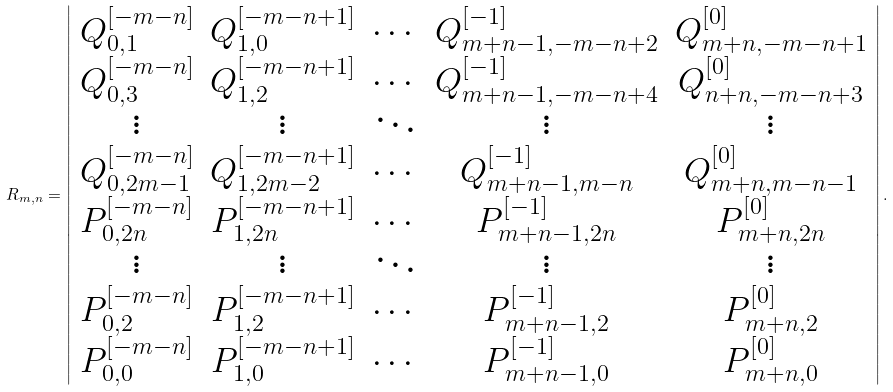Convert formula to latex. <formula><loc_0><loc_0><loc_500><loc_500>R _ { m , n } = \left | \begin{array} { c c c c c } Q _ { 0 , 1 } ^ { [ - m - n ] } & Q _ { 1 , 0 } ^ { [ - m - n + 1 ] } & \cdots & Q _ { m + n - 1 , - m - n + 2 } ^ { [ - 1 ] } & Q _ { m + n , - m - n + 1 } ^ { [ 0 ] } \\ Q _ { 0 , 3 } ^ { [ - m - n ] } & Q _ { 1 , 2 } ^ { [ - m - n + 1 ] } & \cdots & Q _ { m + n - 1 , - m - n + 4 } ^ { [ - 1 ] } & Q _ { n + n , - m - n + 3 } ^ { [ 0 ] } \\ \vdots & \vdots & \ddots & \vdots & \vdots \\ Q _ { 0 , 2 m - 1 } ^ { [ - m - n ] } & Q _ { 1 , 2 m - 2 } ^ { [ - m - n + 1 ] } & \cdots & Q _ { m + n - 1 , m - n } ^ { [ - 1 ] } & Q _ { m + n , m - n - 1 } ^ { [ 0 ] } \\ P _ { 0 , 2 n } ^ { [ - m - n ] } & P _ { 1 , 2 n } ^ { [ - m - n + 1 ] } & \cdots & P _ { m + n - 1 , 2 n } ^ { [ - 1 ] } & P _ { m + n , 2 n } ^ { [ 0 ] } \\ \vdots & \vdots & \ddots & \vdots & \vdots \\ P _ { 0 , 2 } ^ { [ - m - n ] } & P _ { 1 , 2 } ^ { [ - m - n + 1 ] } & \cdots & P _ { m + n - 1 , 2 } ^ { [ - 1 ] } & P _ { m + n , 2 } ^ { [ 0 ] } \\ P _ { 0 , 0 } ^ { [ - m - n ] } & P _ { 1 , 0 } ^ { [ - m - n + 1 ] } & \cdots & P _ { m + n - 1 , 0 } ^ { [ - 1 ] } & P _ { m + n , 0 } ^ { [ 0 ] } \end{array} \right | .</formula> 